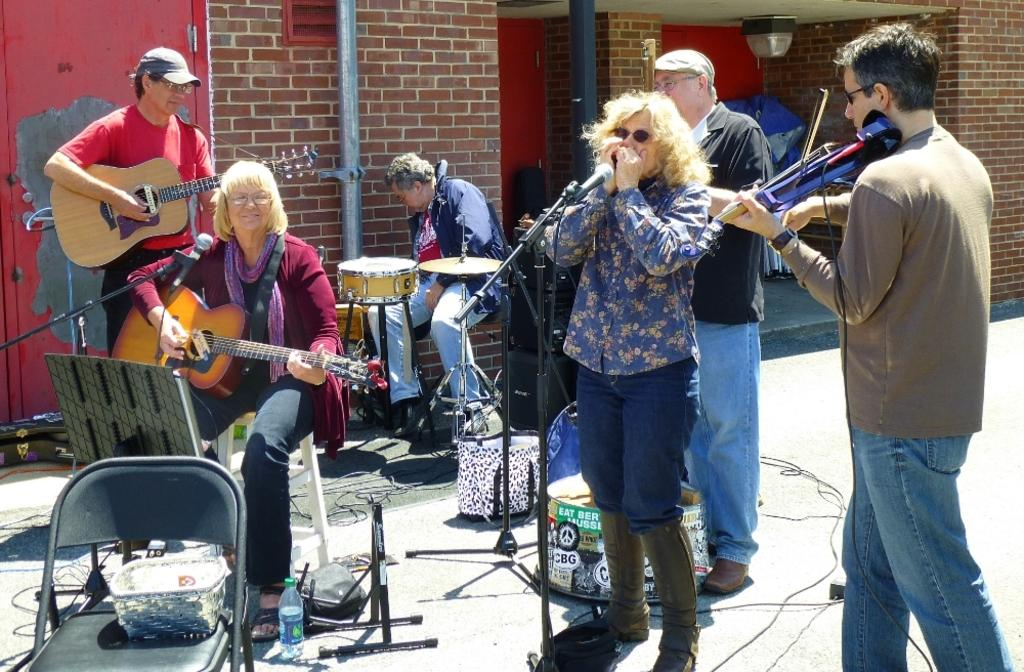What type of group is present in the image? There is a band of musicians in the image. Where are the musicians performing? The musicians are performing on a footpath. What is the texture of the wilderness in the image? There is no wilderness present in the image; the musicians are performing on a footpath. 